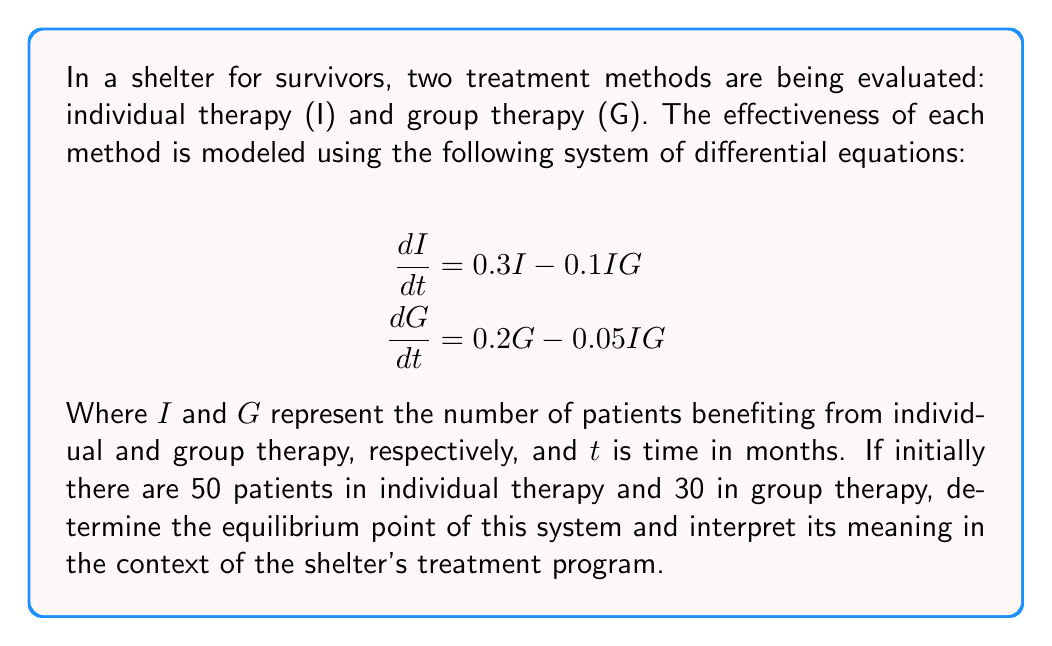Can you answer this question? To solve this problem, we need to follow these steps:

1) Find the equilibrium point by setting both derivatives to zero:

   $$\frac{dI}{dt} = 0.3I - 0.1IG = 0$$
   $$\frac{dG}{dt} = 0.2G - 0.05IG = 0$$

2) From the first equation:
   $$0.3I - 0.1IG = 0$$
   $$I(0.3 - 0.1G) = 0$$
   
   This is satisfied when $I = 0$ or $G = 3$

3) From the second equation:
   $$0.2G - 0.05IG = 0$$
   $$G(0.2 - 0.05I) = 0$$
   
   This is satisfied when $G = 0$ or $I = 4$

4) Combining these results, we find that the non-trivial equilibrium point is $(I, G) = (4, 3)$

5) To interpret this result:
   - At equilibrium, 4 patients will be benefiting from individual therapy
   - At equilibrium, 3 patients will be benefiting from group therapy
   - This equilibrium suggests that over time, regardless of the initial numbers, the system will tend towards a state where 4 patients are effectively treated with individual therapy and 3 with group therapy

6) It's important to note that this equilibrium point is lower than the initial numbers (50 and 30). This could indicate that:
   - The model might be accounting for patients leaving the shelter over time
   - The effectiveness of the treatments might decrease as patients progress in their recovery
   - There might be limitations in resources or capacity that prevent maintaining higher numbers in the long term
Answer: The equilibrium point of the system is $(I, G) = (4, 3)$, meaning that in the long term, the shelter's treatment program is expected to effectively support 4 patients with individual therapy and 3 patients with group therapy, regardless of the initial numbers. 